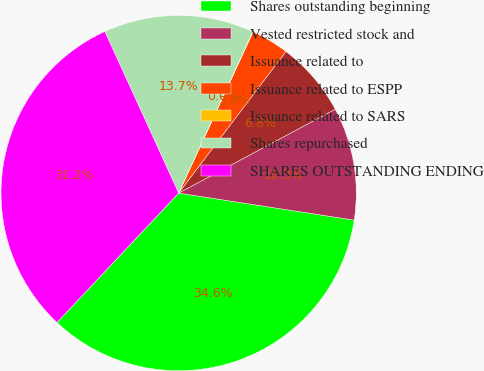Convert chart. <chart><loc_0><loc_0><loc_500><loc_500><pie_chart><fcel>Shares outstanding beginning<fcel>Vested restricted stock and<fcel>Issuance related to<fcel>Issuance related to ESPP<fcel>Issuance related to SARS<fcel>Shares repurchased<fcel>SHARES OUTSTANDING ENDING<nl><fcel>34.58%<fcel>10.26%<fcel>6.85%<fcel>3.44%<fcel>0.03%<fcel>13.67%<fcel>31.17%<nl></chart> 